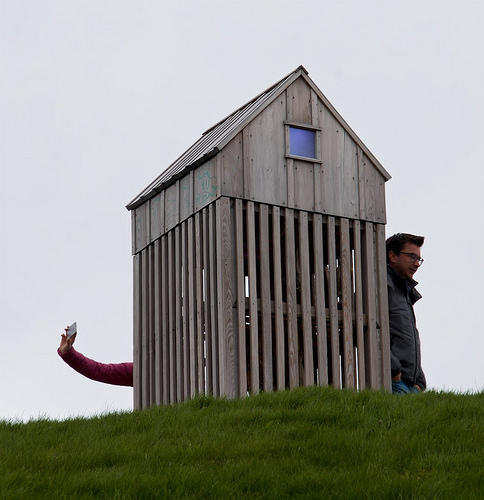<image>
Can you confirm if the person is behind the house? Yes. From this viewpoint, the person is positioned behind the house, with the house partially or fully occluding the person. 